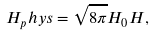<formula> <loc_0><loc_0><loc_500><loc_500>H _ { p } h y s = \sqrt { 8 \pi } H _ { 0 } H ,</formula> 